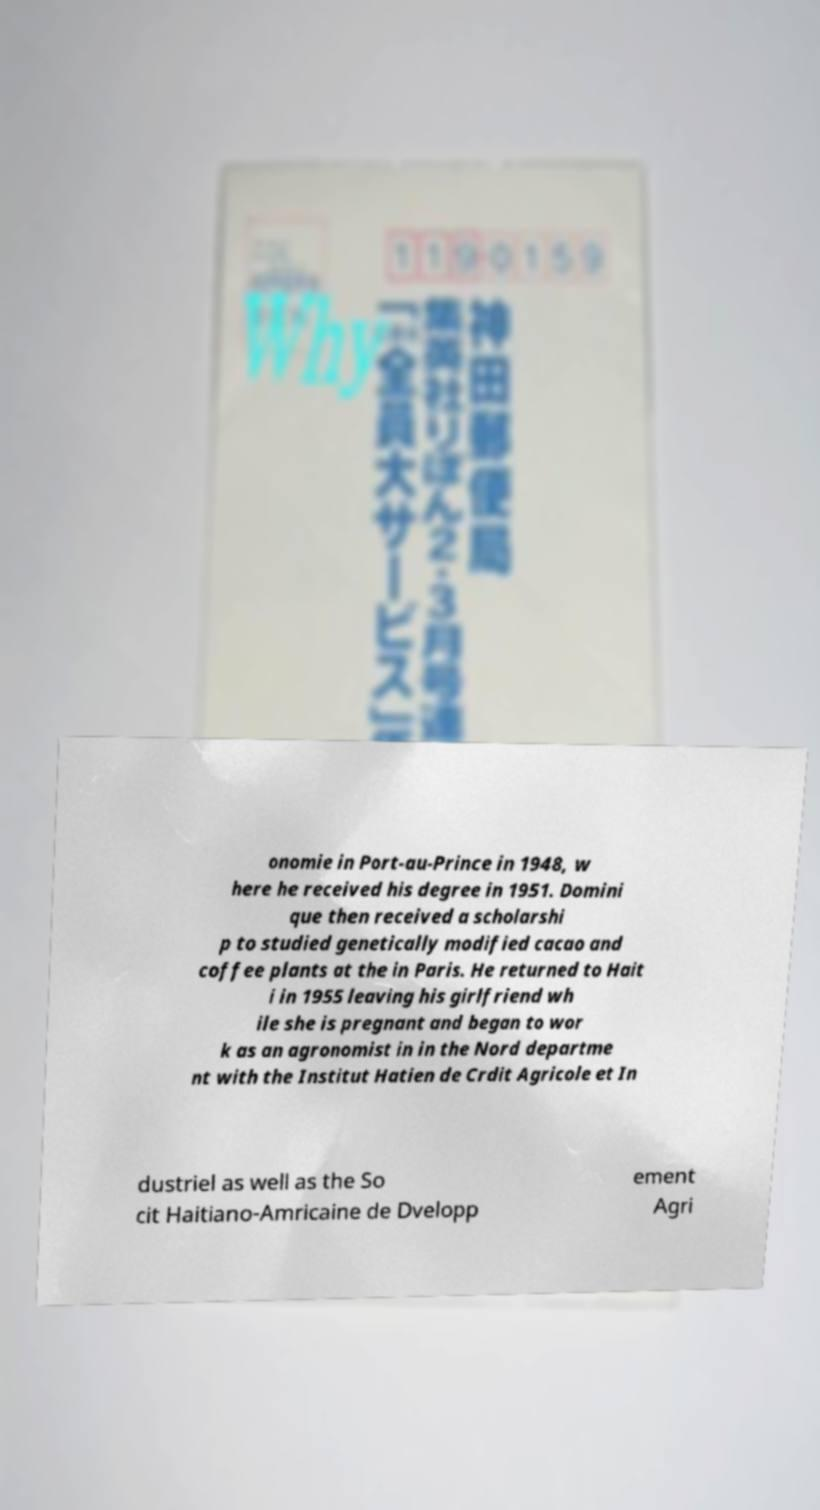Please read and relay the text visible in this image. What does it say? onomie in Port-au-Prince in 1948, w here he received his degree in 1951. Domini que then received a scholarshi p to studied genetically modified cacao and coffee plants at the in Paris. He returned to Hait i in 1955 leaving his girlfriend wh ile she is pregnant and began to wor k as an agronomist in in the Nord departme nt with the Institut Hatien de Crdit Agricole et In dustriel as well as the So cit Haitiano-Amricaine de Dvelopp ement Agri 